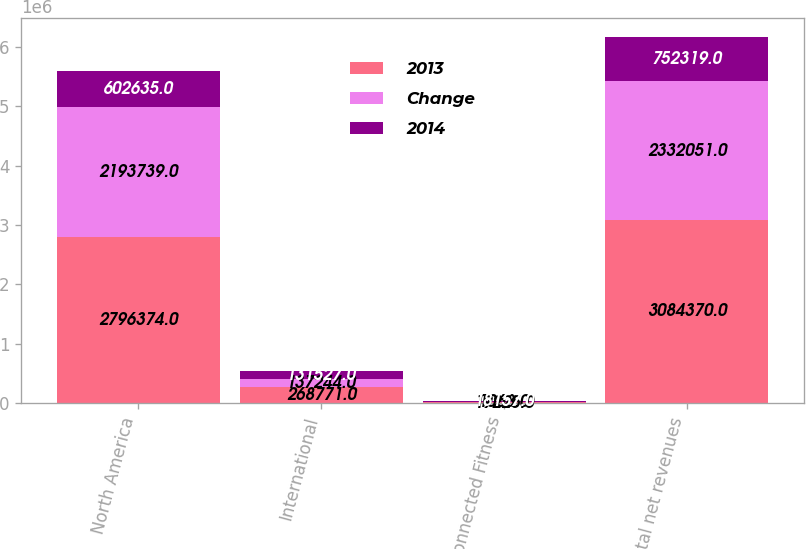Convert chart to OTSL. <chart><loc_0><loc_0><loc_500><loc_500><stacked_bar_chart><ecel><fcel>North America<fcel>International<fcel>Connected Fitness<fcel>Total net revenues<nl><fcel>2013<fcel>2.79637e+06<fcel>268771<fcel>19225<fcel>3.08437e+06<nl><fcel>Change<fcel>2.19374e+06<fcel>137244<fcel>1068<fcel>2.33205e+06<nl><fcel>2014<fcel>602635<fcel>131527<fcel>18157<fcel>752319<nl></chart> 